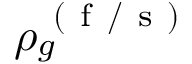Convert formula to latex. <formula><loc_0><loc_0><loc_500><loc_500>\rho _ { g } ^ { ( f / s ) }</formula> 